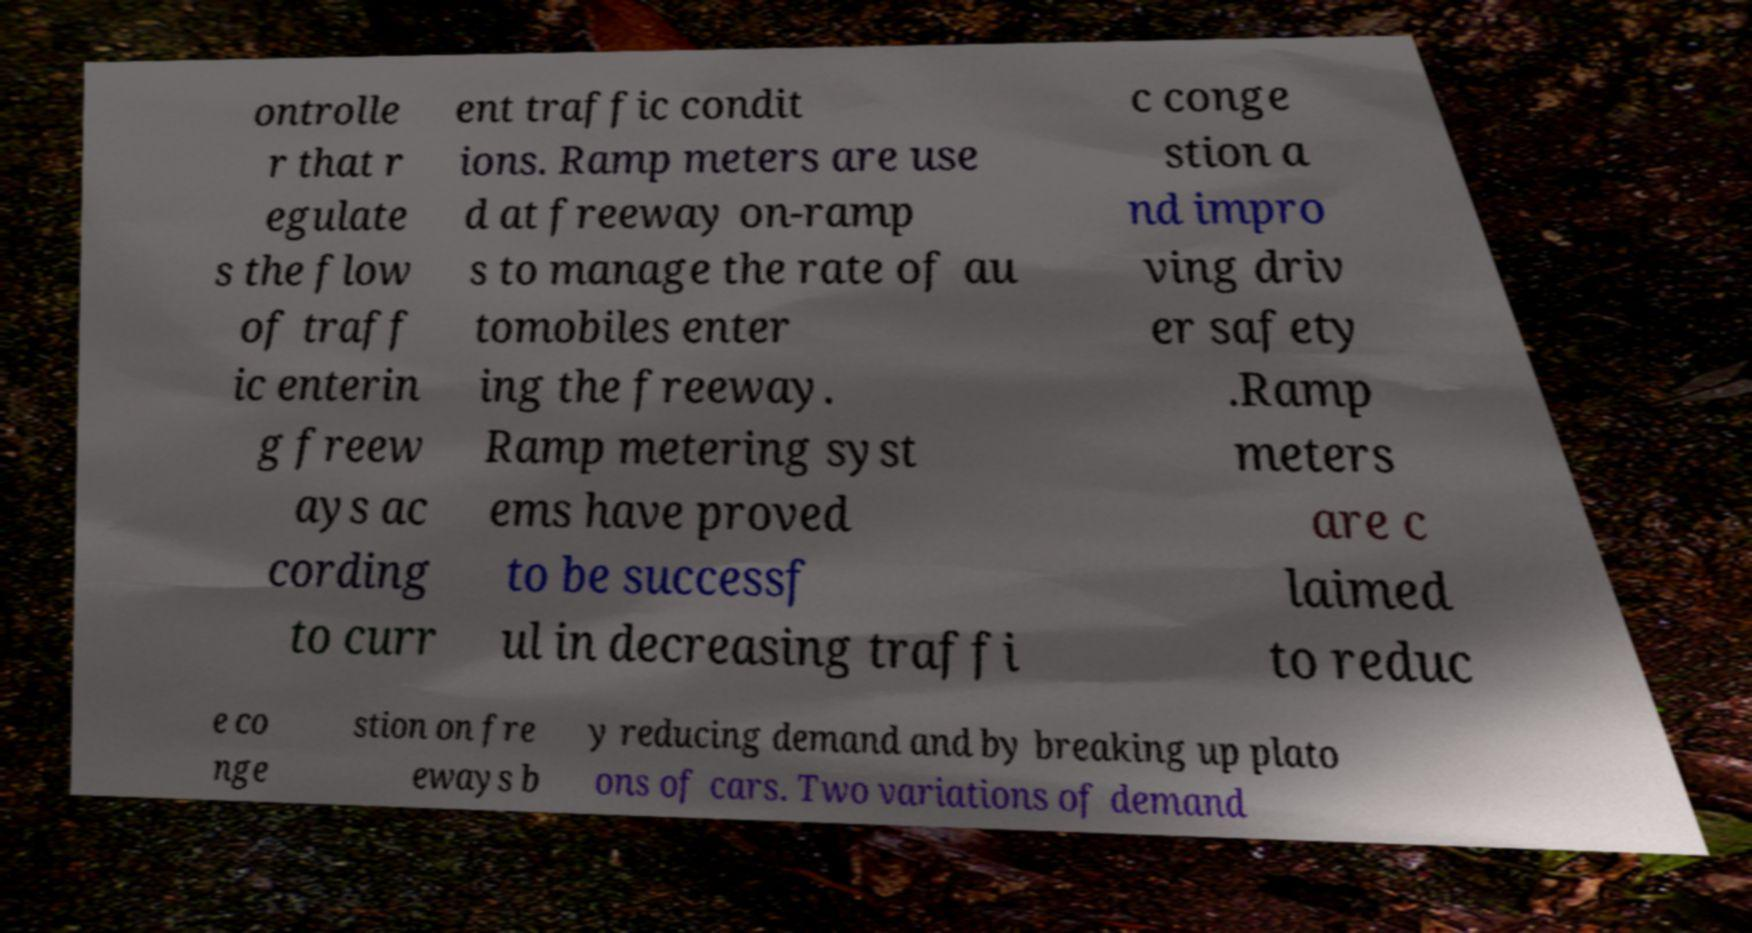Please read and relay the text visible in this image. What does it say? ontrolle r that r egulate s the flow of traff ic enterin g freew ays ac cording to curr ent traffic condit ions. Ramp meters are use d at freeway on-ramp s to manage the rate of au tomobiles enter ing the freeway. Ramp metering syst ems have proved to be successf ul in decreasing traffi c conge stion a nd impro ving driv er safety .Ramp meters are c laimed to reduc e co nge stion on fre eways b y reducing demand and by breaking up plato ons of cars. Two variations of demand 